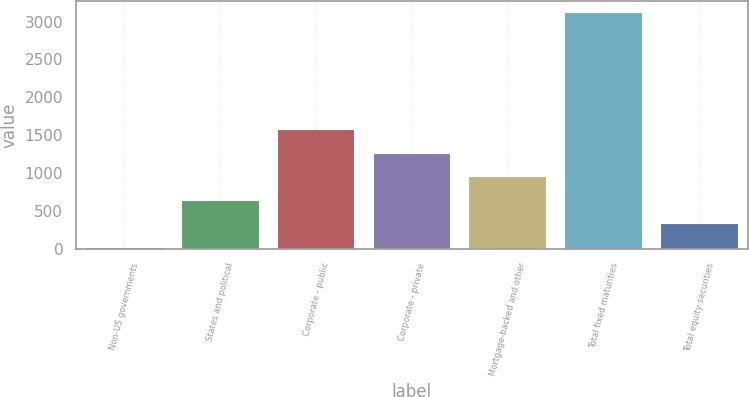Convert chart to OTSL. <chart><loc_0><loc_0><loc_500><loc_500><bar_chart><fcel>Non-US governments<fcel>States and political<fcel>Corporate - public<fcel>Corporate - private<fcel>Mortgage-backed and other<fcel>Total fixed maturities<fcel>Total equity securities<nl><fcel>12.3<fcel>632.84<fcel>1563.65<fcel>1253.38<fcel>943.11<fcel>3115<fcel>322.57<nl></chart> 